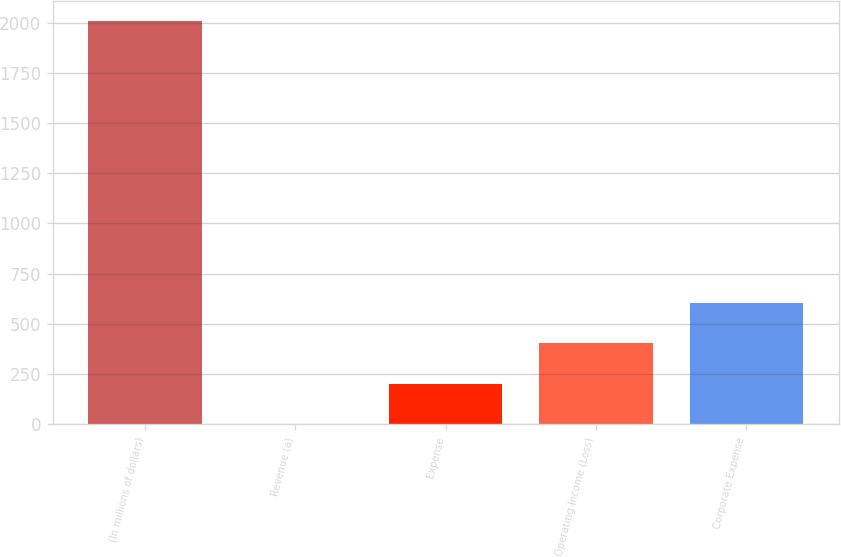Convert chart. <chart><loc_0><loc_0><loc_500><loc_500><bar_chart><fcel>(In millions of dollars)<fcel>Revenue (a)<fcel>Expense<fcel>Operating Income (Loss)<fcel>Corporate Expense<nl><fcel>2010<fcel>1<fcel>201.9<fcel>402.8<fcel>603.7<nl></chart> 